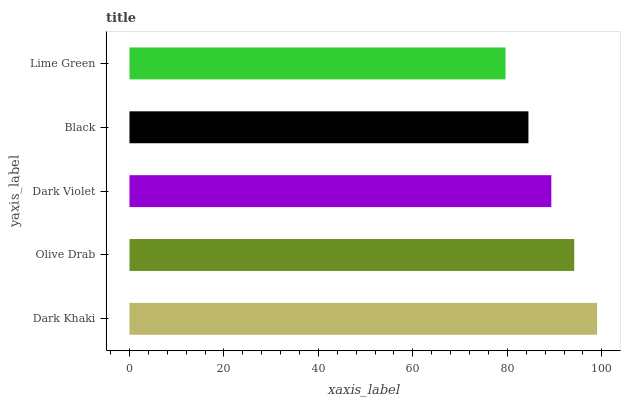Is Lime Green the minimum?
Answer yes or no. Yes. Is Dark Khaki the maximum?
Answer yes or no. Yes. Is Olive Drab the minimum?
Answer yes or no. No. Is Olive Drab the maximum?
Answer yes or no. No. Is Dark Khaki greater than Olive Drab?
Answer yes or no. Yes. Is Olive Drab less than Dark Khaki?
Answer yes or no. Yes. Is Olive Drab greater than Dark Khaki?
Answer yes or no. No. Is Dark Khaki less than Olive Drab?
Answer yes or no. No. Is Dark Violet the high median?
Answer yes or no. Yes. Is Dark Violet the low median?
Answer yes or no. Yes. Is Olive Drab the high median?
Answer yes or no. No. Is Black the low median?
Answer yes or no. No. 